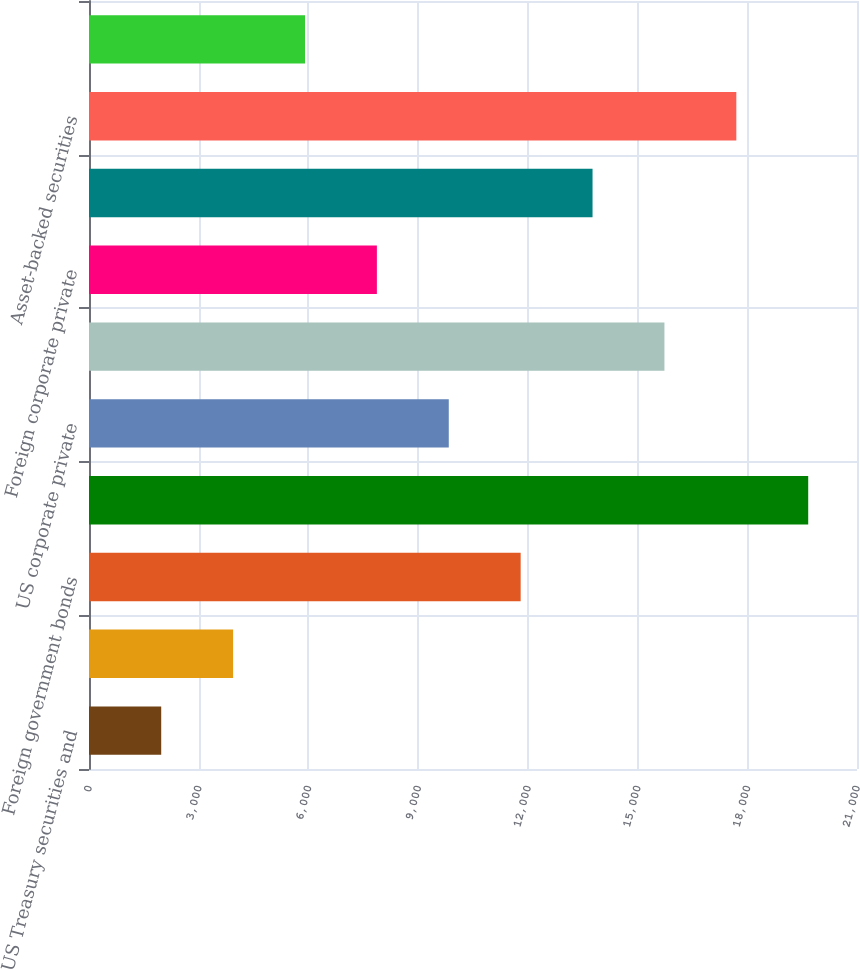Convert chart to OTSL. <chart><loc_0><loc_0><loc_500><loc_500><bar_chart><fcel>US Treasury securities and<fcel>Obligations of US states and<fcel>Foreign government bonds<fcel>US corporate public securities<fcel>US corporate private<fcel>Foreign corporate public<fcel>Foreign corporate private<fcel>Commercial mortgage-backed<fcel>Asset-backed securities<fcel>Residential mortgage-backed<nl><fcel>1974.7<fcel>3940.4<fcel>11803.2<fcel>19666<fcel>9837.5<fcel>15734.6<fcel>7871.8<fcel>13768.9<fcel>17700.3<fcel>5906.1<nl></chart> 